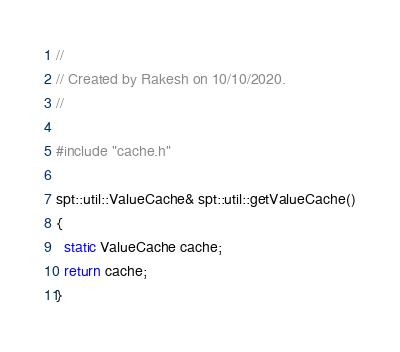Convert code to text. <code><loc_0><loc_0><loc_500><loc_500><_C++_>//
// Created by Rakesh on 10/10/2020.
//

#include "cache.h"

spt::util::ValueCache& spt::util::getValueCache()
{
  static ValueCache cache;
  return cache;
}

</code> 